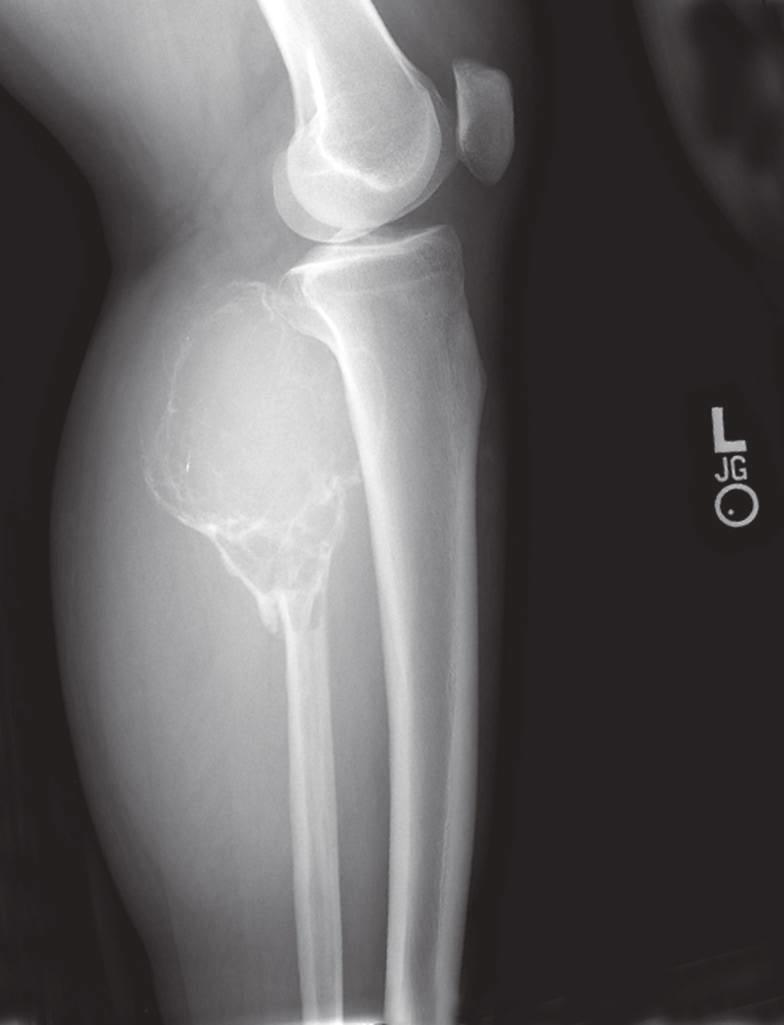s a pathologic fracture also present?
Answer the question using a single word or phrase. Yes 